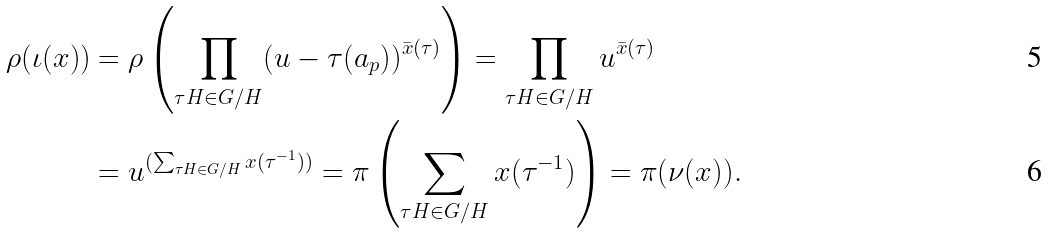<formula> <loc_0><loc_0><loc_500><loc_500>\rho ( \iota ( x ) ) & = \rho \left ( \prod _ { \tau H \in G / H } ( u - \tau ( a _ { p } ) ) ^ { \bar { x } ( \tau ) } \right ) = \prod _ { \tau H \in G / H } u ^ { \bar { x } ( \tau ) } \\ & = u ^ { ( \sum _ { \tau H \in G / H } x ( \tau ^ { - 1 } ) ) } = \pi \left ( \sum _ { \tau H \in G / H } x ( \tau ^ { - 1 } ) \right ) = \pi ( \nu ( x ) ) .</formula> 